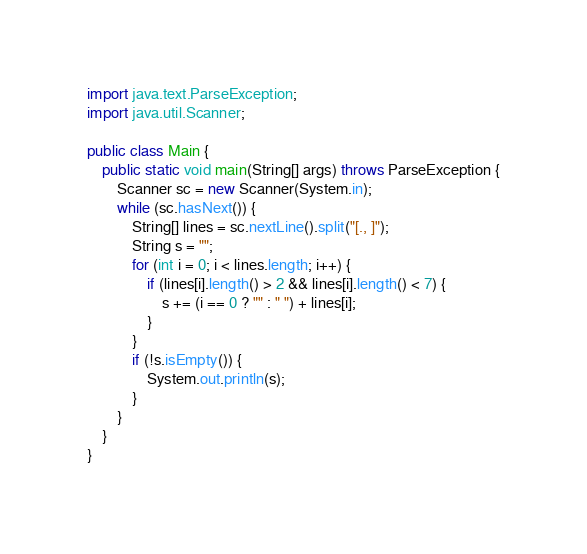<code> <loc_0><loc_0><loc_500><loc_500><_Java_>import java.text.ParseException;
import java.util.Scanner;

public class Main {
    public static void main(String[] args) throws ParseException {
        Scanner sc = new Scanner(System.in);
        while (sc.hasNext()) {
            String[] lines = sc.nextLine().split("[., ]");
            String s = "";
            for (int i = 0; i < lines.length; i++) {
                if (lines[i].length() > 2 && lines[i].length() < 7) {
                    s += (i == 0 ? "" : " ") + lines[i];
                }
            }
            if (!s.isEmpty()) {
                System.out.println(s);
            }
        }
    }
}
</code> 